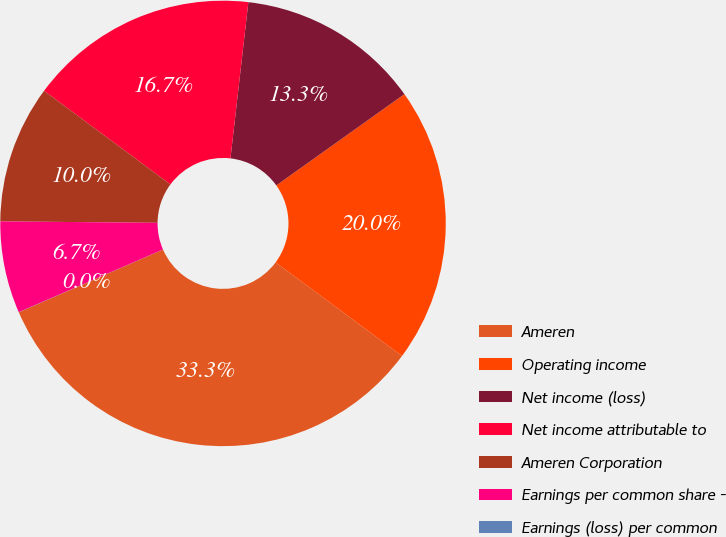<chart> <loc_0><loc_0><loc_500><loc_500><pie_chart><fcel>Ameren<fcel>Operating income<fcel>Net income (loss)<fcel>Net income attributable to<fcel>Ameren Corporation<fcel>Earnings per common share -<fcel>Earnings (loss) per common<nl><fcel>33.32%<fcel>20.0%<fcel>13.33%<fcel>16.67%<fcel>10.0%<fcel>6.67%<fcel>0.01%<nl></chart> 